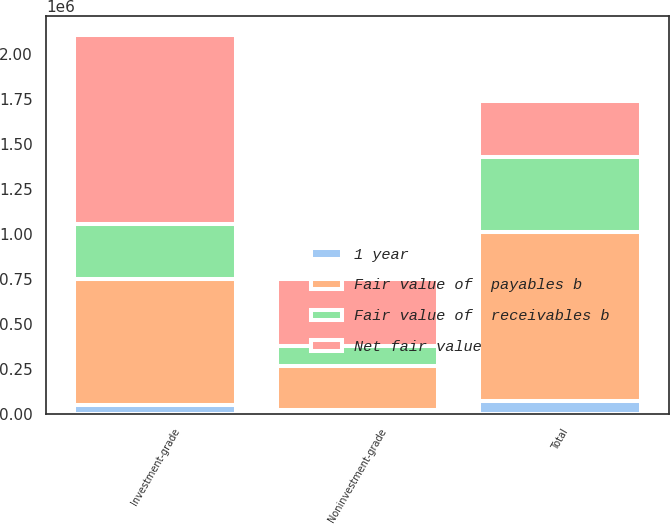Convert chart to OTSL. <chart><loc_0><loc_0><loc_500><loc_500><stacked_bar_chart><ecel><fcel>Investment-grade<fcel>Noninvestment-grade<fcel>Total<nl><fcel>Fair value of  receivables b<fcel>307211<fcel>109195<fcel>416406<nl><fcel>Fair value of  payables b<fcel>699227<fcel>245151<fcel>944378<nl><fcel>1 year<fcel>46970<fcel>21085<fcel>68055<nl><fcel>Net fair value<fcel>1.05341e+06<fcel>375431<fcel>307211<nl></chart> 